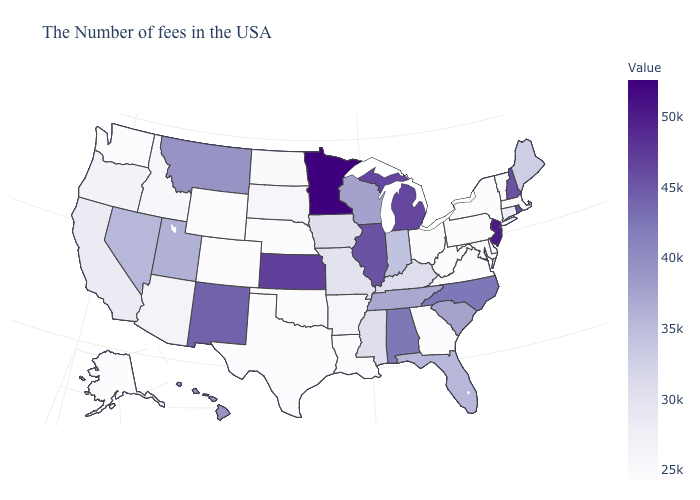Which states have the lowest value in the USA?
Write a very short answer. Massachusetts, New York, Delaware, Maryland, Pennsylvania, Virginia, West Virginia, Ohio, Georgia, Louisiana, Nebraska, Texas, Wyoming, Colorado, Washington, Alaska. Among the states that border Oregon , which have the lowest value?
Concise answer only. Washington. Does Kansas have the lowest value in the USA?
Short answer required. No. Among the states that border Texas , which have the lowest value?
Short answer required. Louisiana. 